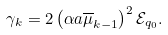Convert formula to latex. <formula><loc_0><loc_0><loc_500><loc_500>\gamma _ { k } = 2 \left ( \alpha a { \overline { \mu } _ { k - 1 } } \right ) ^ { 2 } \mathcal { E } _ { q _ { 0 } } .</formula> 